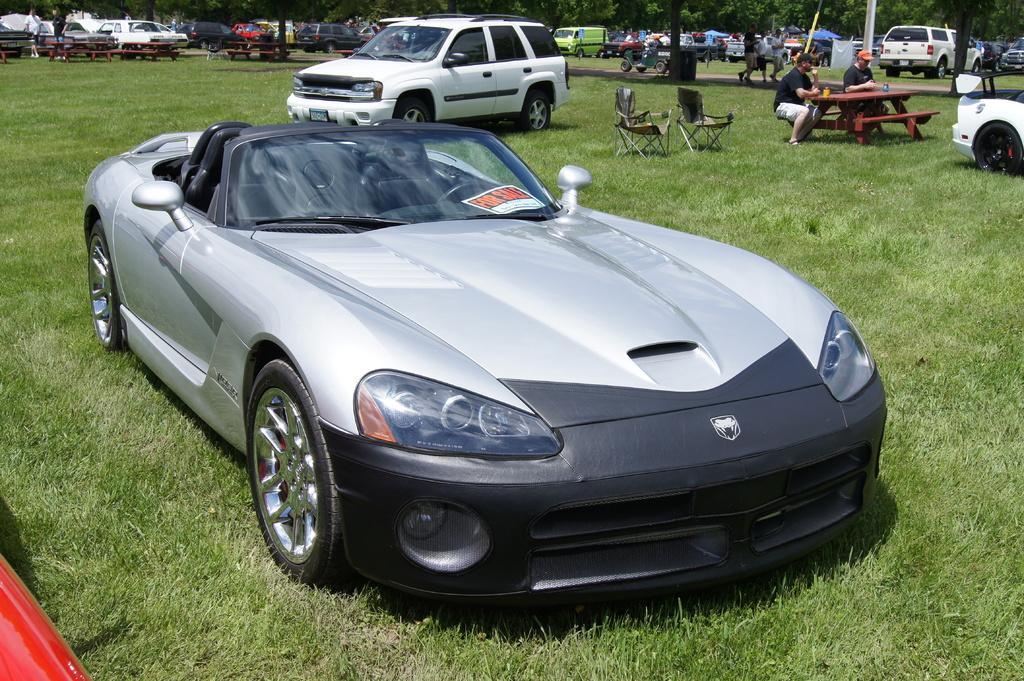Could you give a brief overview of what you see in this image? In this image we can see vehicles, grass, chairs, tables, people, and trees. Here we can see two persons are sitting on a bench. 